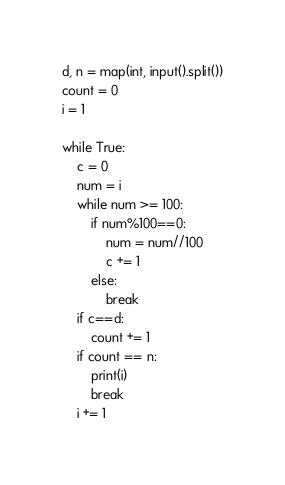Convert code to text. <code><loc_0><loc_0><loc_500><loc_500><_Python_>d, n = map(int, input().split())
count = 0
i = 1

while True:
    c = 0
    num = i
    while num >= 100:
        if num%100==0:
            num = num//100
            c += 1
        else:
            break
    if c==d:
        count += 1
    if count == n:
        print(i)
        break
    i += 1</code> 